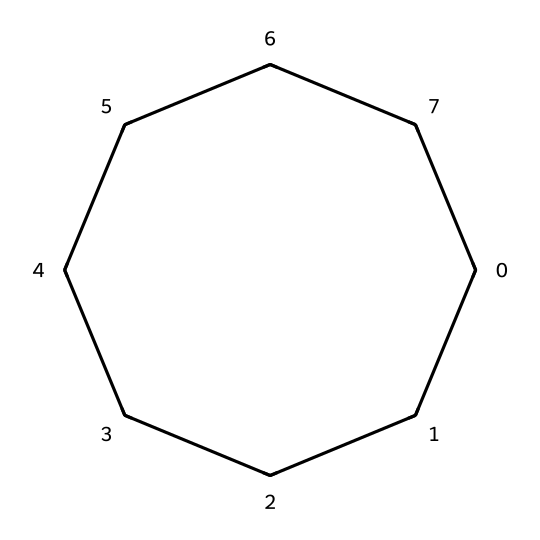What is the name of this chemical? The SMILES representation shows a closed ring of eight carbon atoms, which indicates it is cyclooctane.
Answer: cyclooctane How many carbon atoms does this chemical contain? By analyzing the structure in the SMILES notation, we count eight carbon atoms (C) in the cyclic arrangement.
Answer: eight What type of chemical structure is this? The chemical is represented as a cyclic molecule with single bonds between its carbon atoms, classifying it as a cycloalkane.
Answer: cycloalkane What is the degree of saturation for cyclooctane? Cyclooctane is a saturated hydrocarbon with no double or triple bonds; its degree of saturation is 1 for each carbon in the ring, representing it as fully saturated.
Answer: 1 How many hydrogen atoms are attached to each carbon in cyclooctane? Each carbon in cyclooctane is bonded to two hydrogens, which completes each carbon's tetravalency (four bonds). Given it has 8 carbons, there are 16 hydrogen atoms in total.
Answer: two Does this chemical have any functional groups? Cyclooctane does not contain any functional groups—it is a simple cyclic alkane with only carbon-carbon and carbon-hydrogen single bonds.
Answer: no What is a potential use of cyclooctane? Cyclooctane can be used as a solvent in some cleaning products, particularly computer cleaning solvents due to its effective solvency and low reactivity.
Answer: solvent 